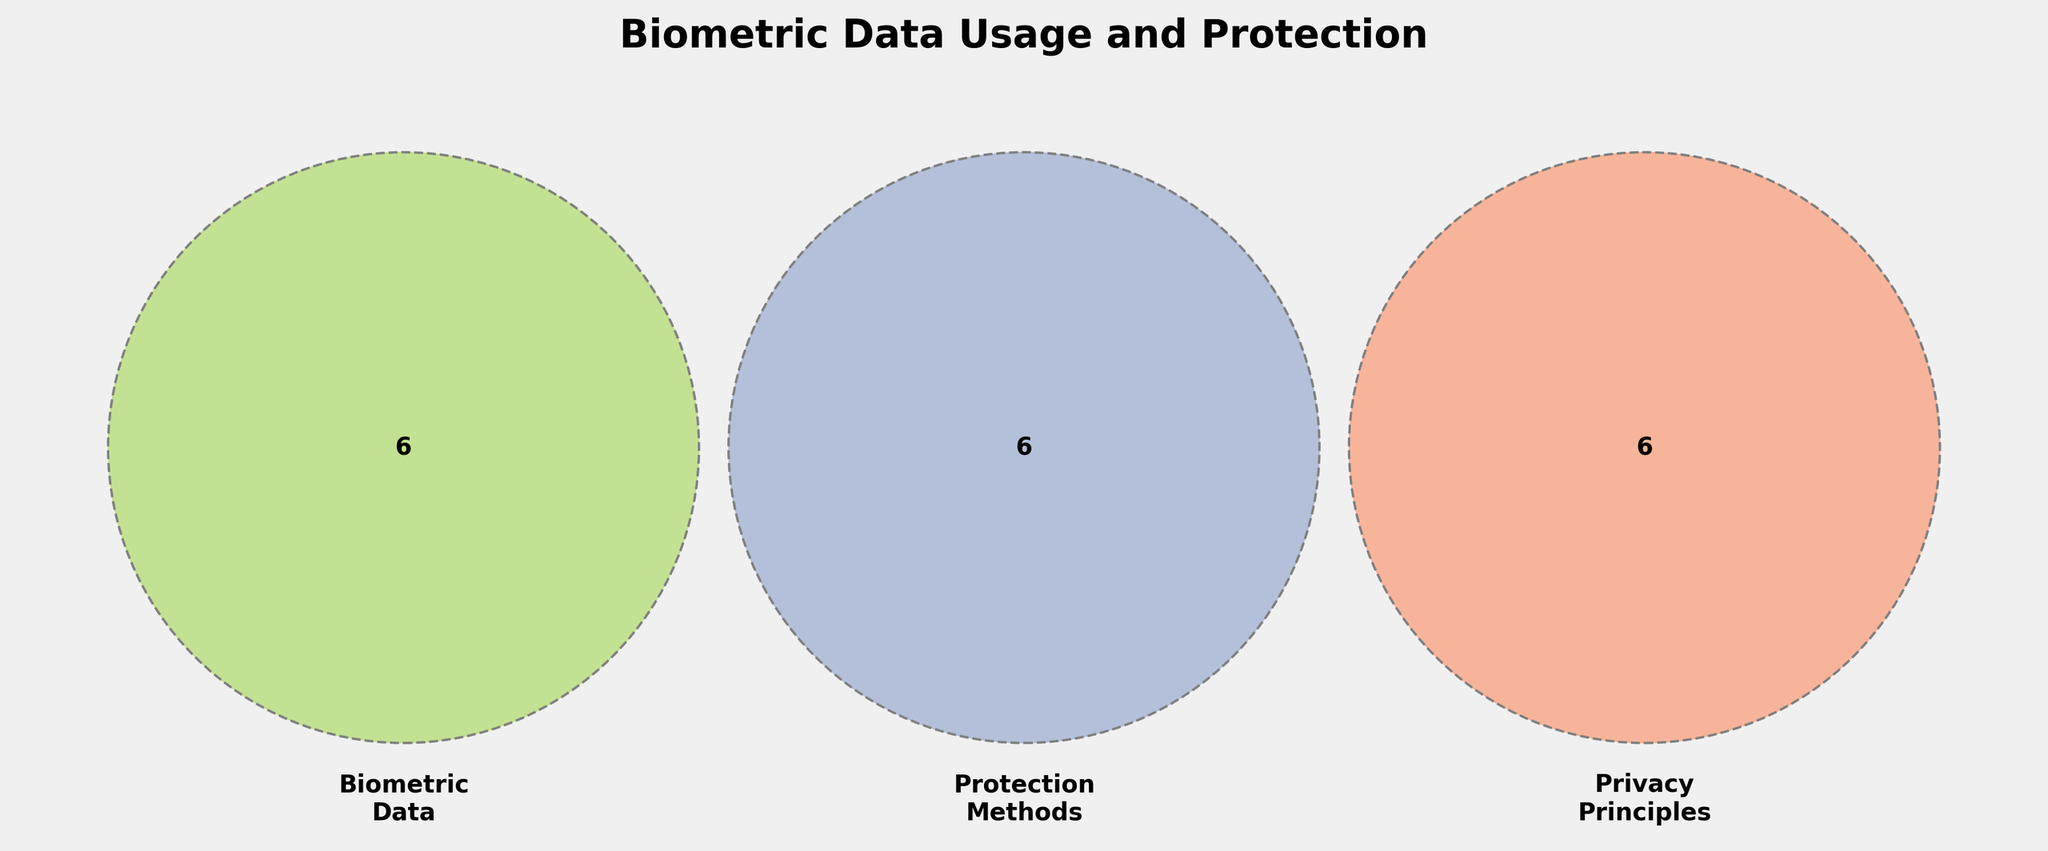What is the title of the plot? The title is displayed at the top of the plot.
Answer: Biometric Data Usage and Protection What are the labels of the three sets in the Venn diagram? The labels are directly shown on the Venn diagram.
Answer: Biometric Data, Protection Methods, Privacy Principles Which elements fall under both 'Biometric Data' and 'Protection Methods'? Look at the region where the circles for 'Biometric Data' and 'Protection Methods' overlap without including 'Privacy Principles.'
Answer: Facial Recognition, Fingerprint Scanning, Iris Recognition, Voice Analysis, Gait Analysis, DNA Profiling Are there any elements that are in all three sets? Check the intersection area of all three circles.
Answer: None Which section has the most elements in 'Privacy Principles'? Count the elements within 'Privacy Principles' circle excluding overlapping regions.
Answer: Right to be Forgotten, Purpose Limitation, Data Portability How many elements are unique to 'Protection Methods'? Count the elements that reside solely within the 'Protection Methods' circle.
Answer: Encryption, Anonymization, Access Control, Blockchain, Homomorphic Encryption, Federated Learning Do 'Gait Analysis' and 'Transparency' share any category? Determine if 'Gait Analysis' and 'Transparency' appear in the same section.
Answer: No Which category includes 'Homomorphic Encryption'? Look within the 'Protection Methods' circle.
Answer: Protection Methods How does 'Blockchain' relate to the three sets? Identify 'Blockchain' in the Venn diagram and note its positioning relative to the three sets.
Answer: Blockchain falls under Protection Methods only Name one element that is common between 'Protection Methods' and 'Privacy Principles.' Look at the overlapping section between 'Protection Methods' and 'Privacy Principles' without including 'Biometric Data.'
Answer: Homomorphic Encryption 